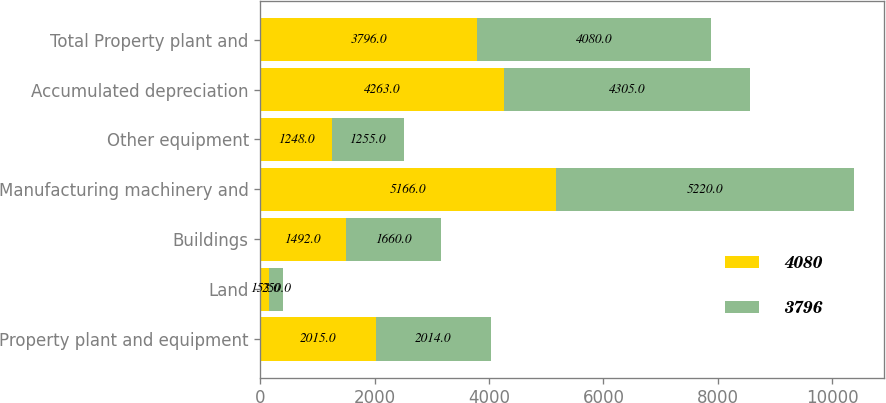Convert chart. <chart><loc_0><loc_0><loc_500><loc_500><stacked_bar_chart><ecel><fcel>Property plant and equipment<fcel>Land<fcel>Buildings<fcel>Manufacturing machinery and<fcel>Other equipment<fcel>Accumulated depreciation<fcel>Total Property plant and<nl><fcel>4080<fcel>2015<fcel>153<fcel>1492<fcel>5166<fcel>1248<fcel>4263<fcel>3796<nl><fcel>3796<fcel>2014<fcel>250<fcel>1660<fcel>5220<fcel>1255<fcel>4305<fcel>4080<nl></chart> 